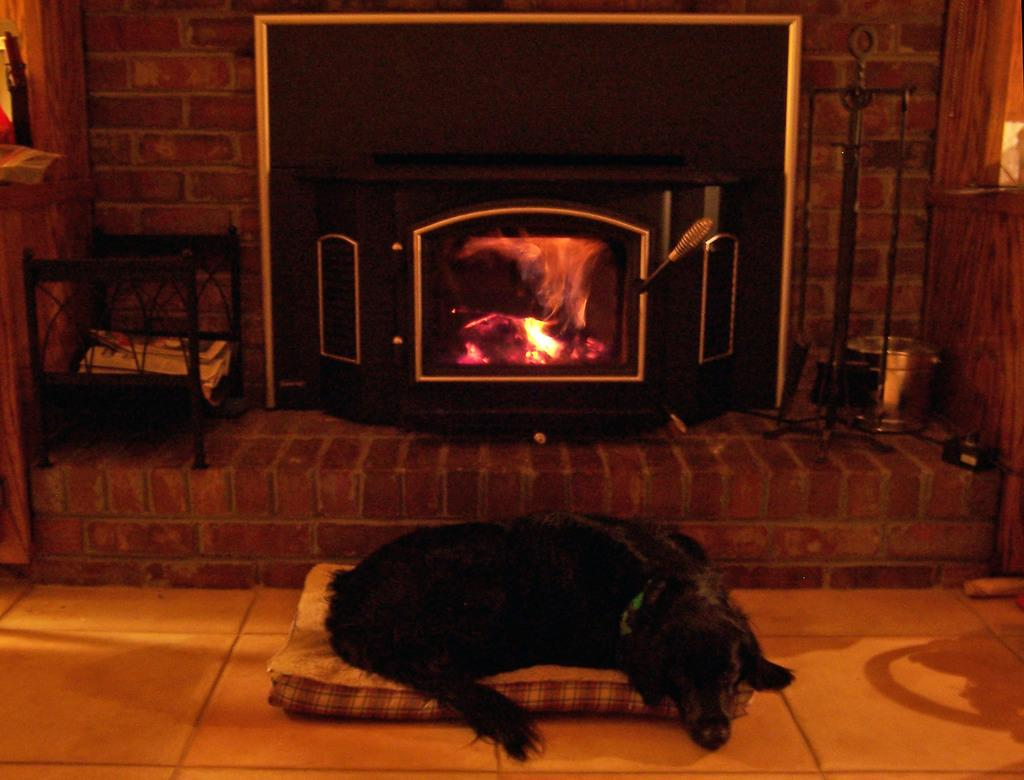What animal is on the bed in the image? There is a dog on the bed in the image. What is the surface beneath the bed? The surface beneath the bed is the floor. What type of appliance can be seen in the image? There is a wooden oven in the image. What type of object is present in the image that might be used for writing or drawing? There are papers in the image. What can be seen in the background of the image? There is a wall visible in the background of the image. Can you tell me how many kitties are playing with the slave in the image? There are no kitties or slaves present in the image. What type of toy is being used by the dog in the image? There is no toy visible in the image; only the dog, bed, floor, wooden oven, papers, and wall are present. 